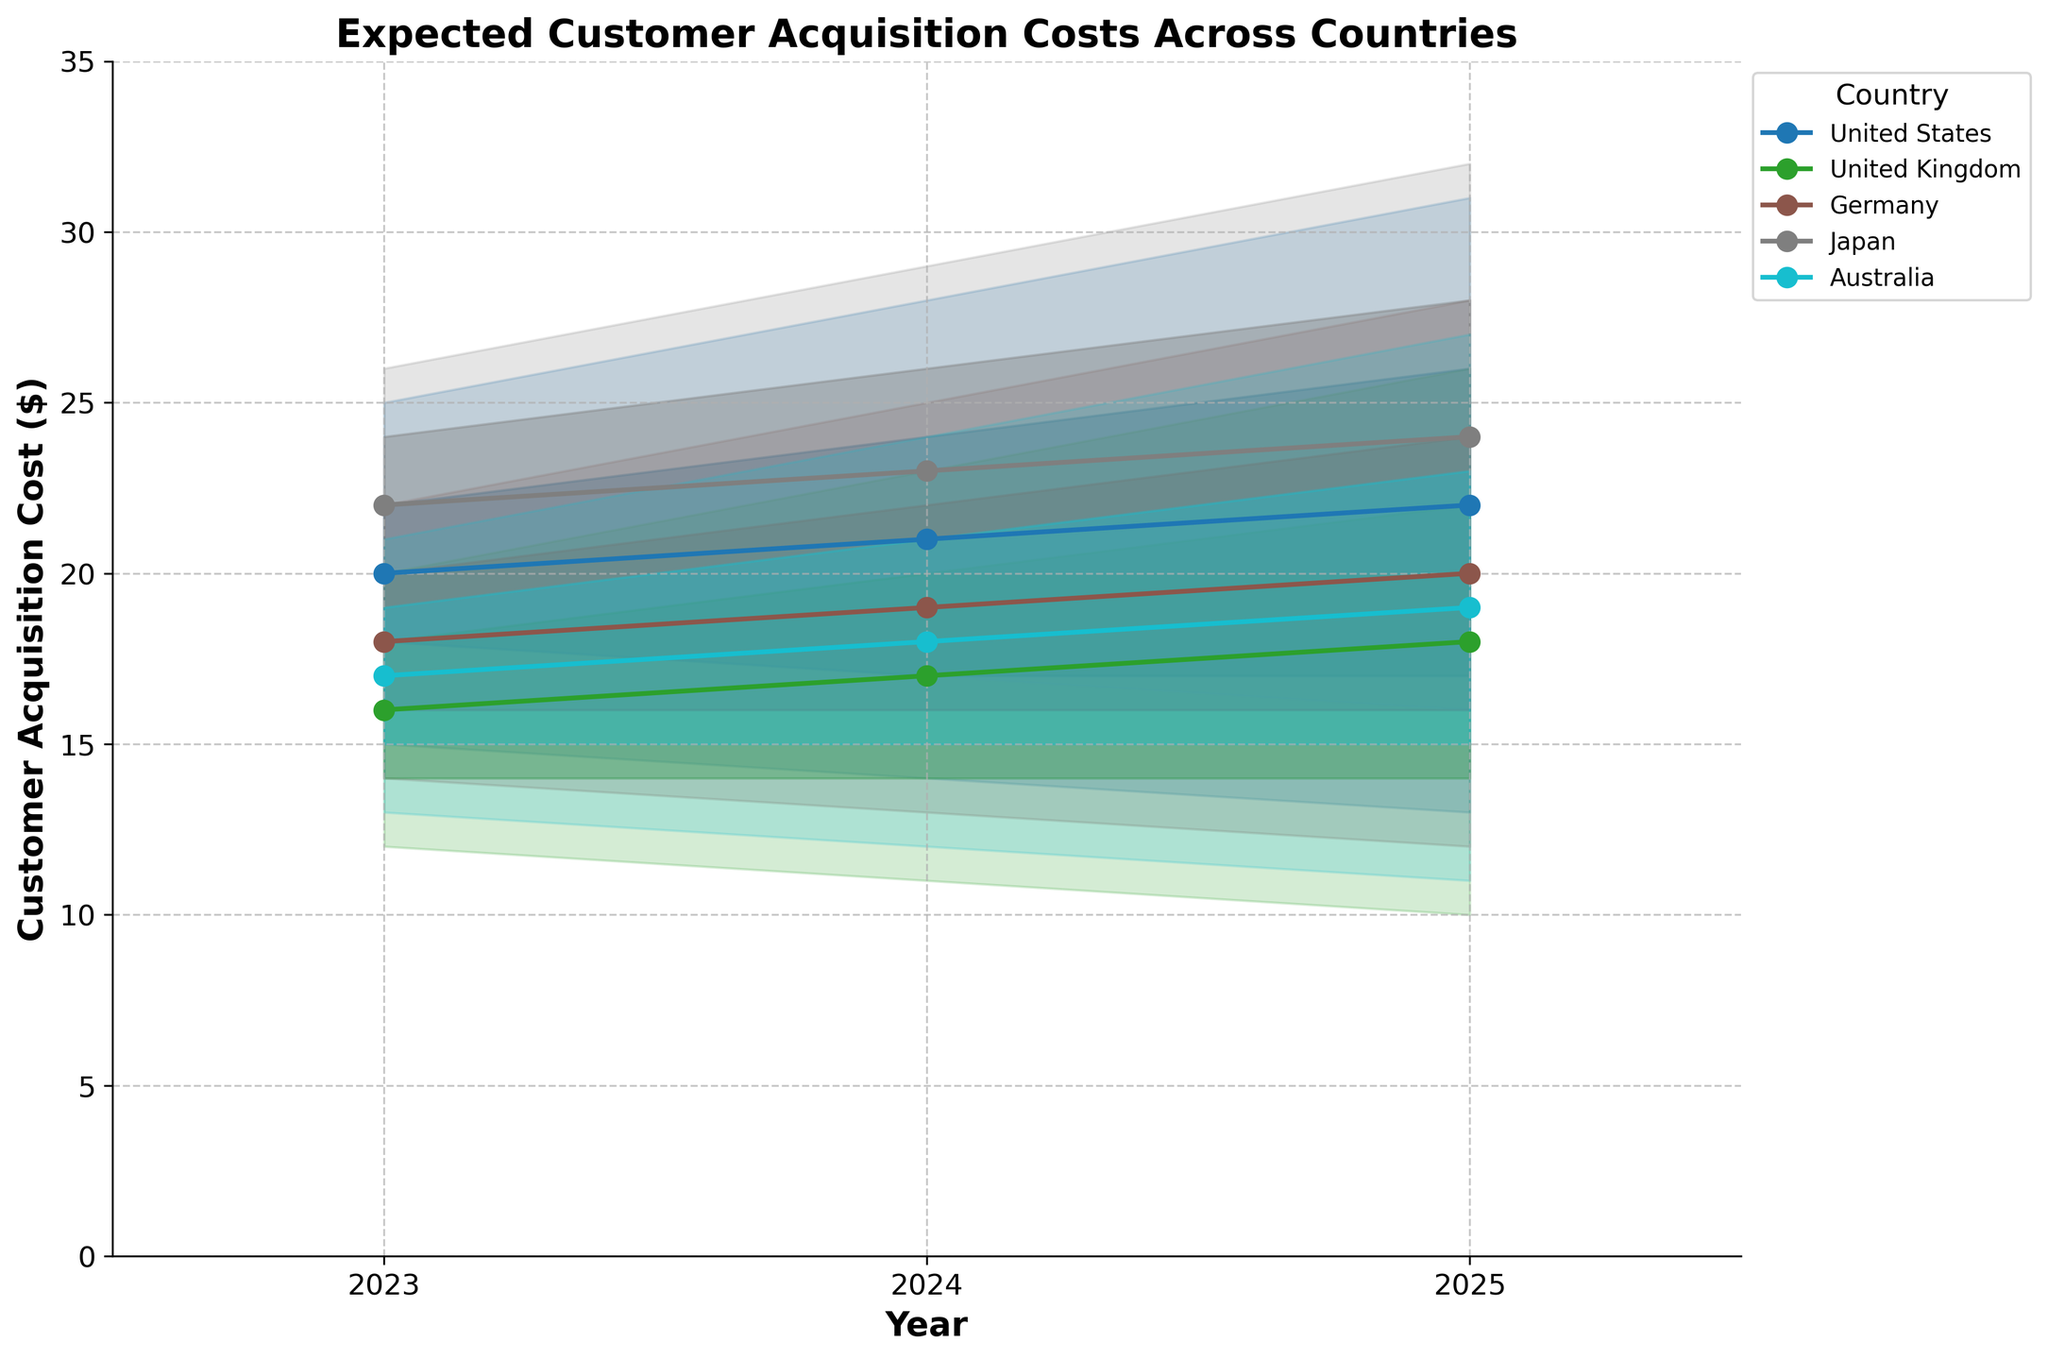What's the title of the figure? The title is the text at the top of the figure, which summarizes what the visual represents. By reading it, you can quickly understand the main topic of the figure.
Answer: Expected Customer Acquisition Costs Across Countries How many countries are represented in the figure? Looking at the legend on the right side of the figure, which lists the different countries shown, you can count the total number.
Answer: 5 Which country has the highest median expected customer acquisition cost in 2025? To find this, look at the median line for each country and find the highest value in the year 2025.
Answer: Japan Does any country show a decreasing trend in the median customer acquisition cost from 2023 to 2025? Reviewing the median lines from 2023 to 2025 for each country, you need to observe if the lines are sloping downward.
Answer: United States, United Kingdom, Germany, Australia What is the range of the 75% confidence interval for Germany in 2024? The 75% confidence interval is the range between the Lower_75 and Upper_75 bounds for Germany in 2024. Subtract the Lower_75 value from the Upper_75 value.
Answer: 6 (22 - 16) Which country has the narrowest uncertainty bands in 2023? To determine this, compare the width of the total uncertainty bands (shaded areas) for each country in 2023.
Answer: Germany Are there any countries where the uncertainty bands get wider from 2023 to 2025? Check if the shaded areas (uncertainty bands) for any country expand over the years from 2023 to 2025.
Answer: Yes, United States, United Kingdom, Japan, Australia What is the difference in the median customer acquisition cost between the United States and Japan in 2023? Subtract the median value for the United States in 2023 from the median value for Japan in 2023.
Answer: 2 (22 - 20) How does the customer acquisition cost in Australia in 2024 compare to 2025? Compare the median values for Australia between 2024 and 2025 to see if it increases, decreases, or remains the same.
Answer: It increases Between which years does the United Kingdom show the largest increase in uncertainty? Compare the width of the uncertainty bands for the United Kingdom between each pair of successive years to see which gap grows the most.
Answer: Between 2024 and 2025 